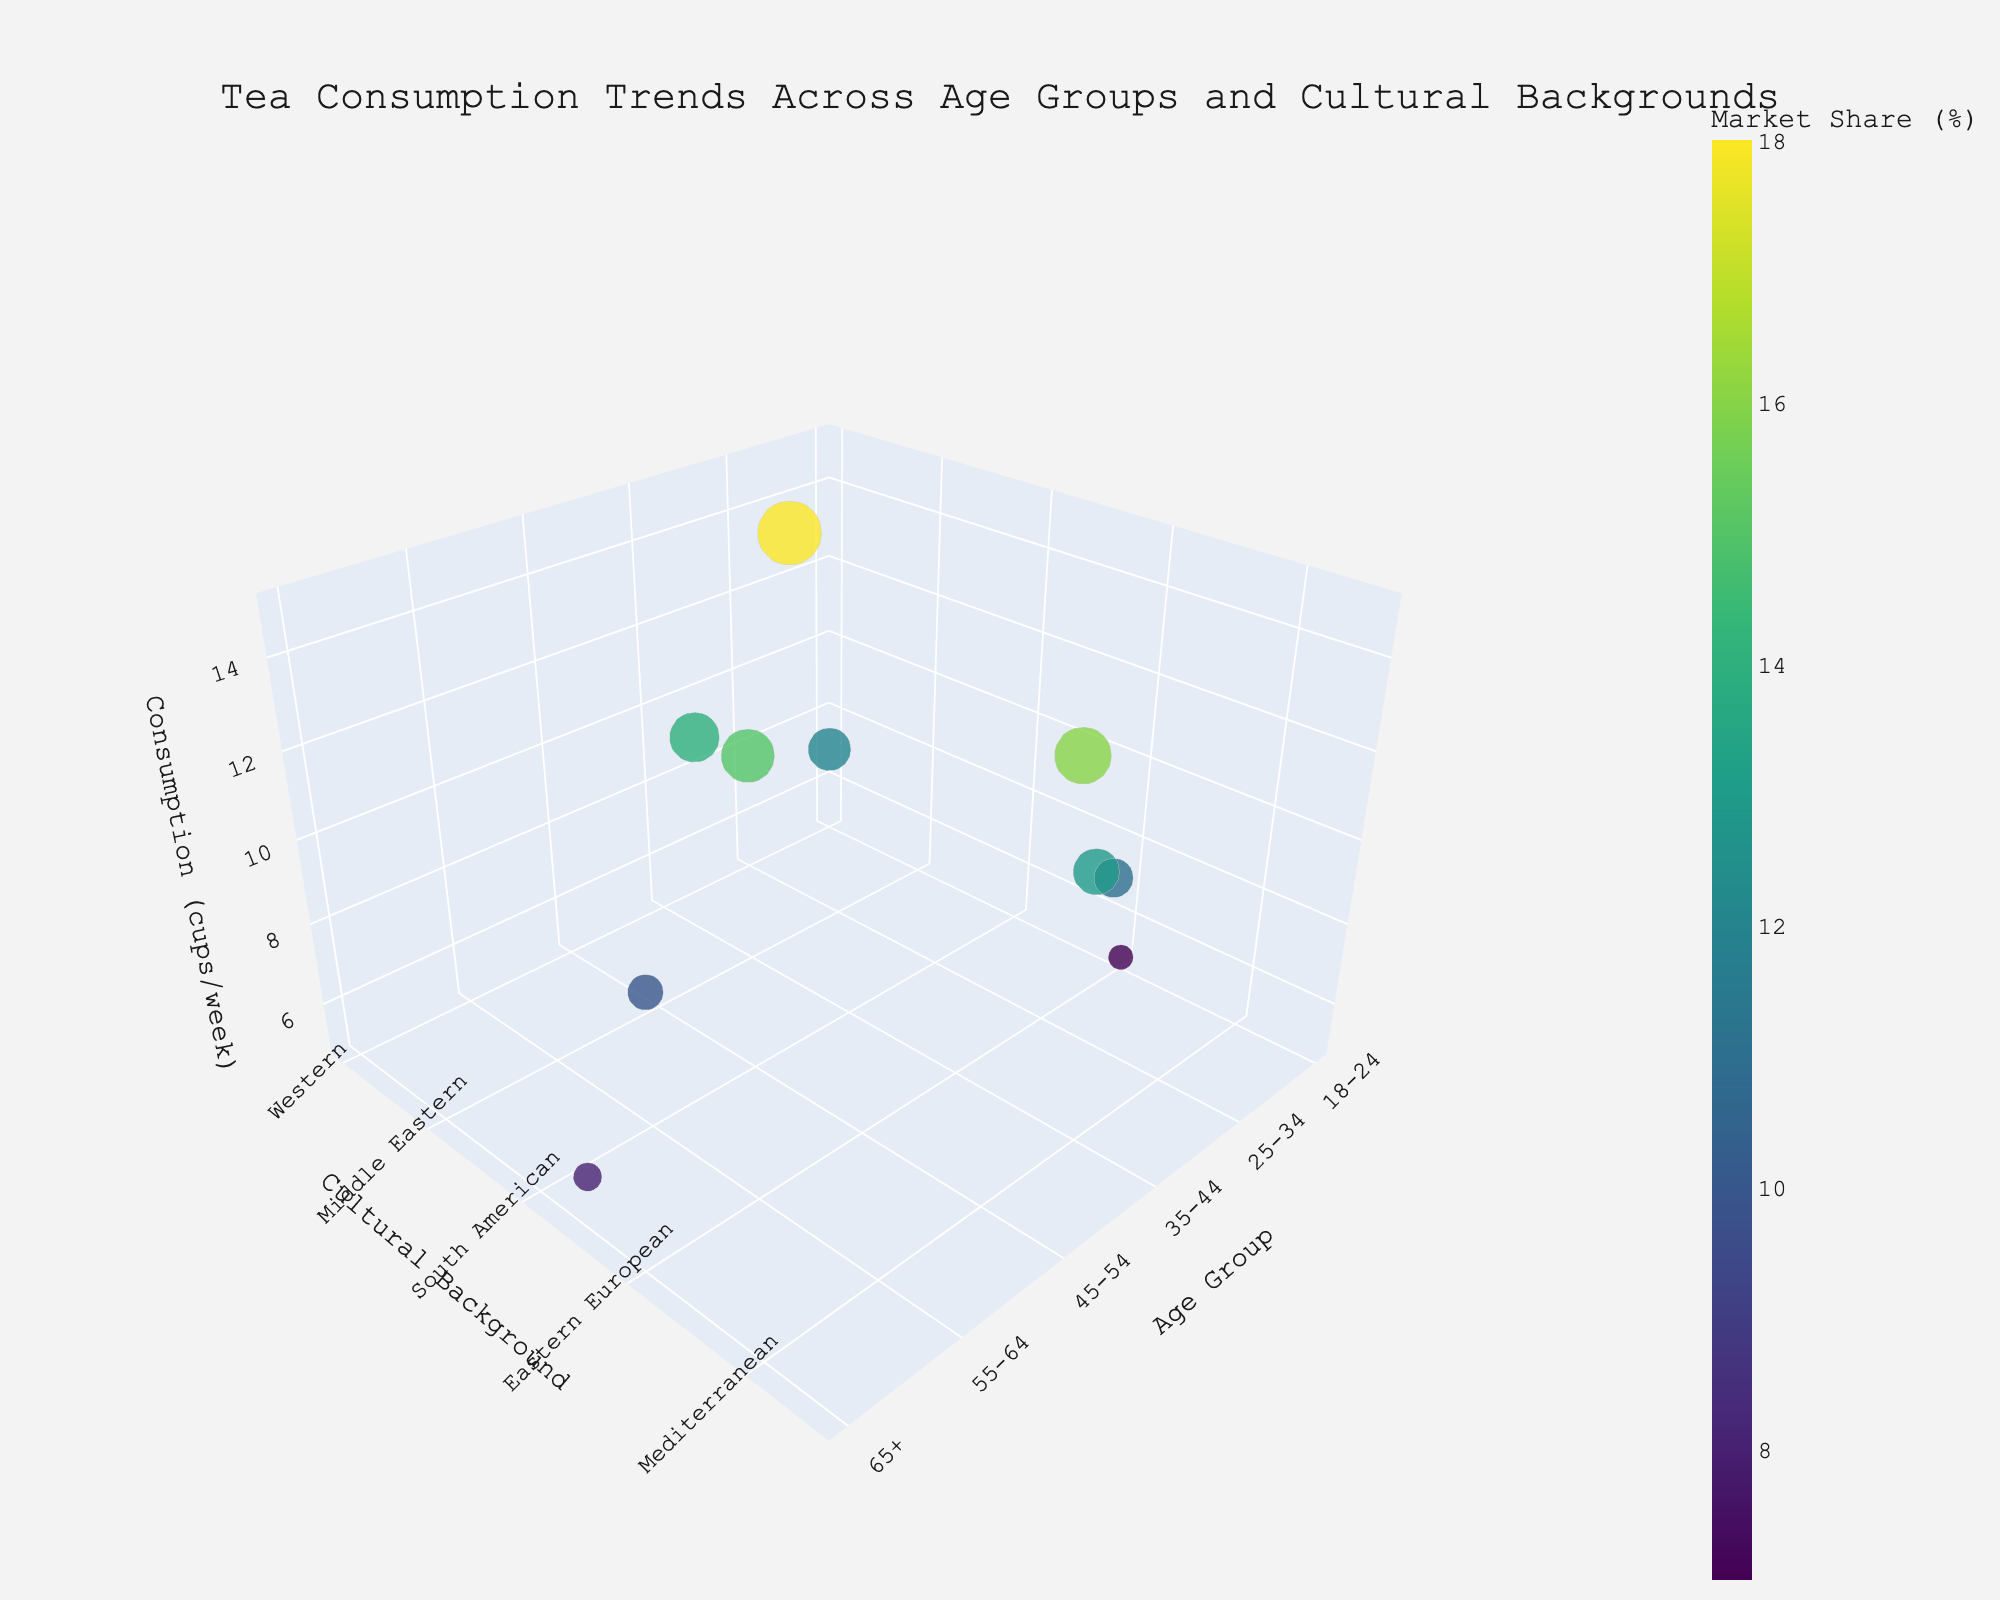What is the title of the chart? The title is visible at the top of the chart, providing a summary of what the chart represents. It reads "Tea Consumption Trends Across Age Groups and Cultural Backgrounds".
Answer: Tea Consumption Trends Across Age Groups and Cultural Backgrounds Which age group consumes the most tea? Look at the z-axis to find the highest point, which represents the highest tea consumption (cups/week). The dot representing age group 25-34 consumes 14 cups/week.
Answer: 25-34 What's the preferred tea type of the 35-44 age group from the Mediterranean cultural background? Locate the data point where the age group is 35-44 and the cultural background is the Mediterranean. The preferred tea type associated with this data point is Jasmine.
Answer: Jasmine How does the market share of the Middle Eastern cultural background compare to the African cultural background? Find and compare the sizes of the bubbles for Middle Eastern (35-44 group, 15%) and African (65+ group, 8%). The Middle Eastern has a larger market share.
Answer: Middle Eastern > African What's the combined tea consumption for the 18-24 age group across all cultural backgrounds? Sum the consumption values (cups/week) for the 18-24 age group. This includes Western (7) and Eastern European (5). Hence, 7 + 5 = 12.
Answer: 12 Which cultural background shows a preference for Green Tea, and what is their consumption rate? Identify the bubble tagged with Green Tea from the hover template. It is associated with the Western cultural background, with a consumption rate of 7 cups/week.
Answer: Western, 7 Compare the tea consumption between the European and South American cultural backgrounds. Which is higher? Locate the data points for European (45-54 group, 12 cups/week) and South American (55-64 group, 8 cups/week). The European consumption is higher.
Answer: European > South American What is the average market share percentage across all data points? Sum the market share percentages from all data points and divide by the number of data points. (12 + 18 + 15 + 14 + 10 + 8 + 7 + 11 + 13 + 16) / 10 = 124 / 10 = 12.4%
Answer: 12.4% Which age group prefers Masala Chai? Look for the bubble tagged with Masala Chai. It is associated with the age group 45-54.
Answer: 45-54 Of the age groups that prefer herbal teas (Chamomile, Rooibos), what is the total market share? Locate the bubbles tagged with Chamomile (55-64 group, 10%) and Rooibos (65+ group, 8%). Sum their market shares, 10% + 8% = 18%.
Answer: 18% 